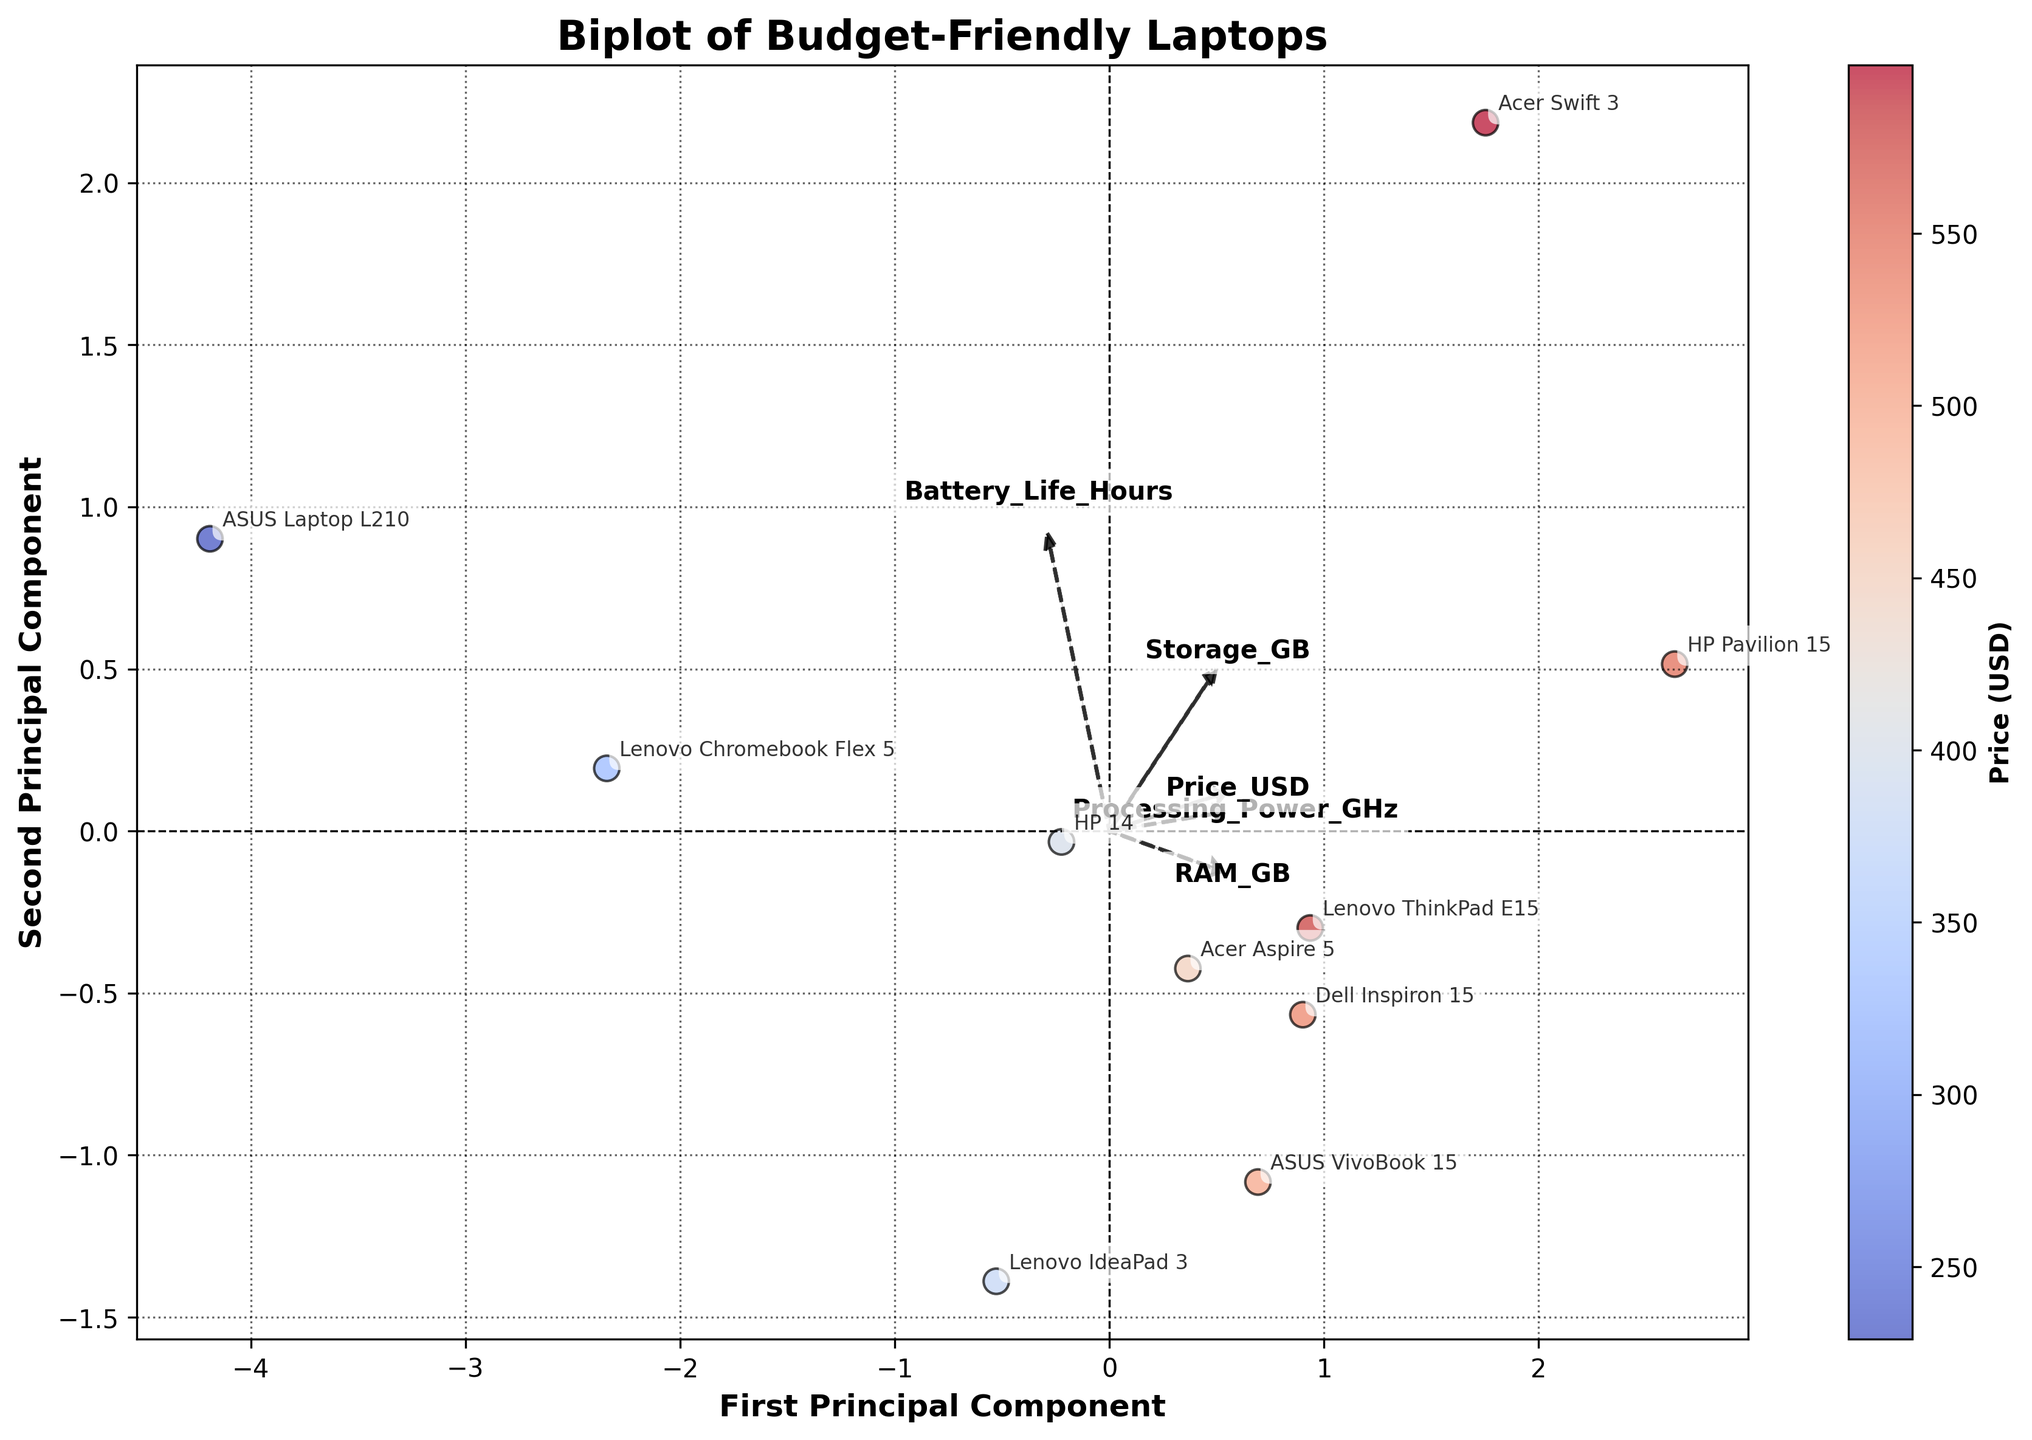What is the title of the biplot? The title is usually found at the top of the figure. By looking at the top, we see the title "Biplot of Budget-Friendly Laptops."
Answer: Biplot of Budget-Friendly Laptops What are the labels on the X and Y axes? The axis labels provide information about the dimensions in the plot. The X-axis is labeled "First Principal Component," and the Y-axis is labeled "Second Principal Component."
Answer: First Principal Component, Second Principal Component How many data points are plotted in the biplot? Each data point corresponds to a laptop model in our dataset. By counting the points, we see there are 10 data points.
Answer: 10 Which laptop model has the highest price? The color intensity on the scatter plot indicates the price, with warmer colors representing higher prices. The "Acer Swift 3" is plotted in the deepest red, indicating it has the highest price among the plotted models.
Answer: Acer Swift 3 Which feature vectors (arrows) contribute most to the variation captured by the first principal component? The longer the projection of an arrow on the x-axis, the more it contributes to the first component. "Price_USD" and "Storage_GB" appear to have the longest projections on the x-axis, suggesting they are the primary contributors.
Answer: Price_USD, Storage_GB How can we describe the relationship between battery life and price from the biplot? The angle between the "Battery_Life_Hours" and "Price_USD" arrows is significant, indicating a potential relationship. Since their vectors are not aligned, the relationship may not be strongly positive or negative. Observing the laptop positions, no clear trend aligns battery life strictly with price.
Answer: Weak relationship Which model has the highest processing power and what is its approximate price? Locate the point farthest to the right along the processing power arrow. The "Acer Swift 3" has the highest processing power. The color indicates it has a high price, confirmed to be the highest.
Answer: Acer Swift 3, $599 Which feature distinguishes laptops with better battery life? The direction and length of the "Battery_Life_Hours" vector show which features correlate. Laptops with longer battery life tend to have moderate to low prices as indicated by the opposite direction of the price vector.
Answer: Moderate to low prices Which two models are closest to each other in terms of principal components? By observing the proximity of data points in the scatter plot, "Lenovo IdeaPad 3" and "HP 14" are closest, suggesting similar overall features.
Answer: Lenovo IdeaPad 3, HP 14 